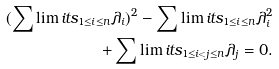Convert formula to latex. <formula><loc_0><loc_0><loc_500><loc_500>( \sum \lim i t s _ { 1 \leq i \leq n } \lambda _ { i } ) ^ { 2 } - \sum \lim i t s _ { 1 \leq i \leq n } \lambda _ { i } ^ { 2 } \\ + \sum \lim i t s _ { 1 \leq i < j \leq n } \lambda _ { j } = 0 .</formula> 